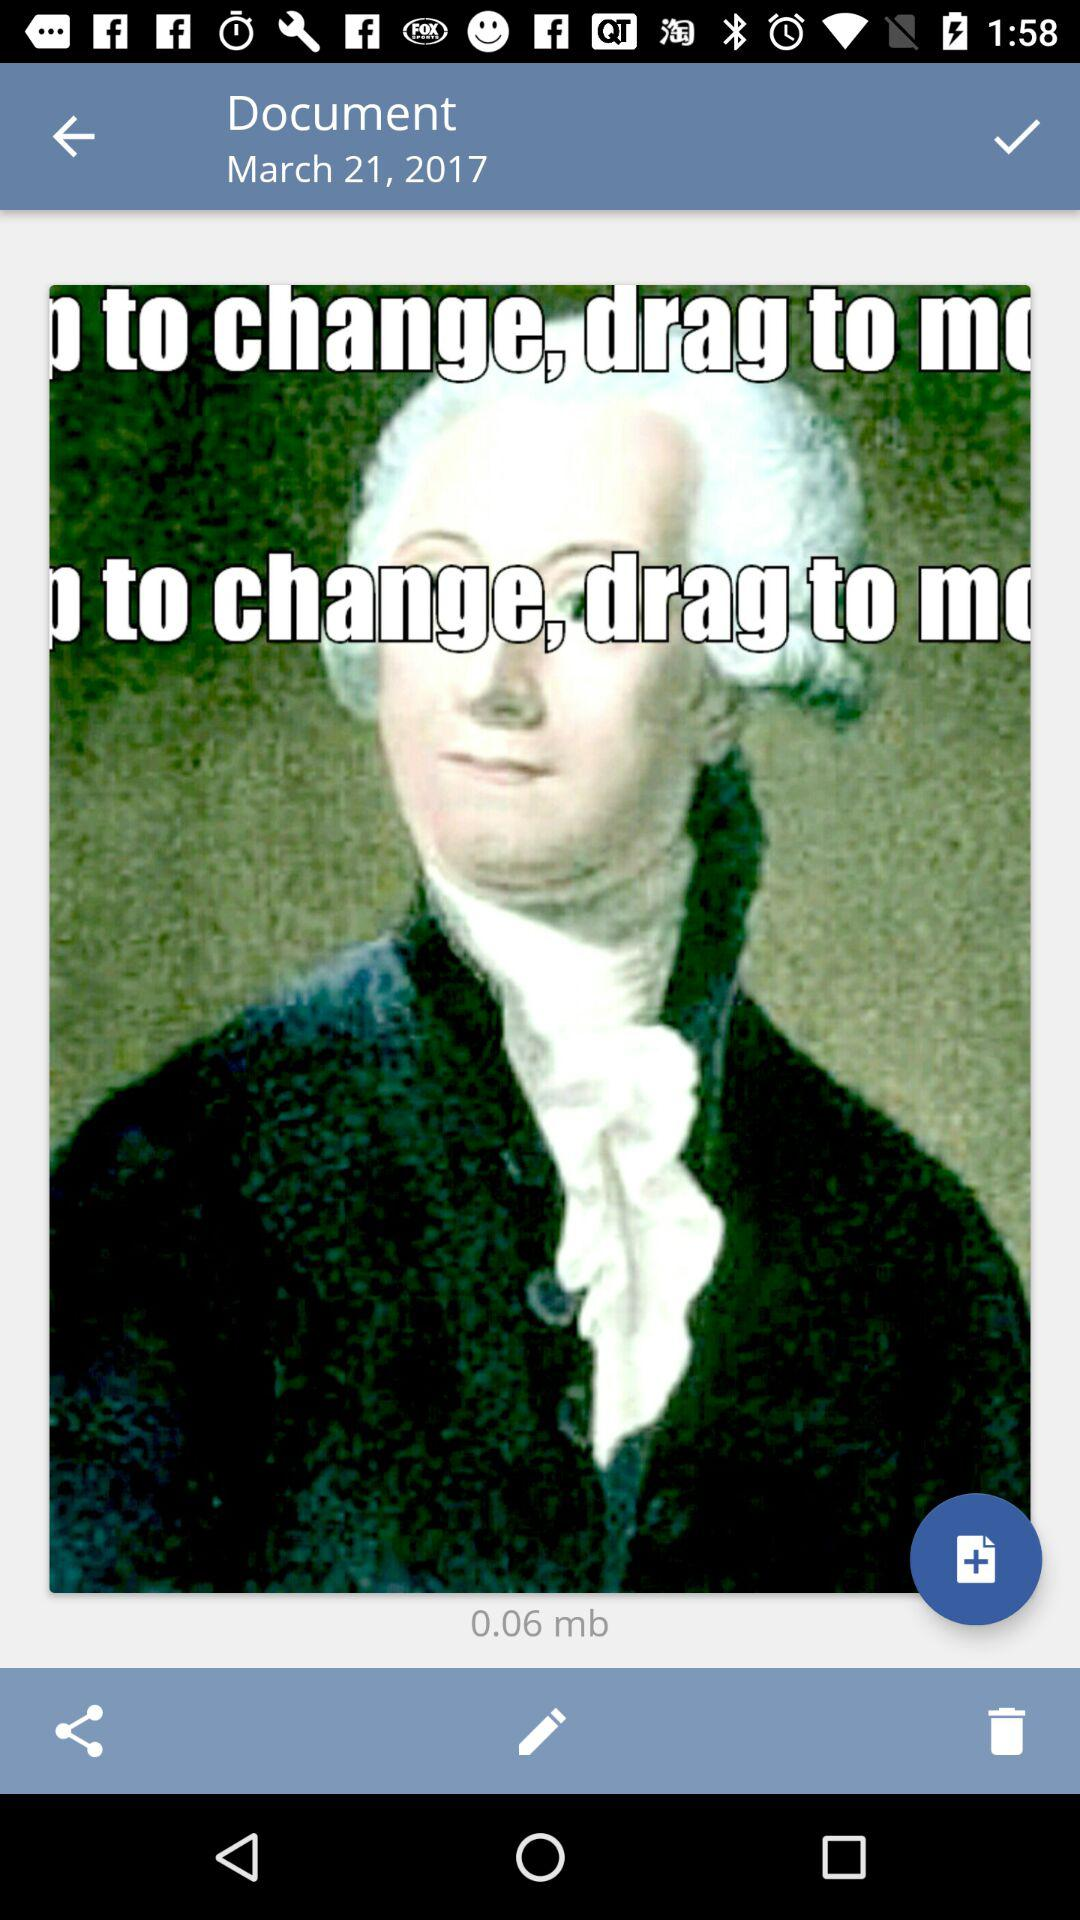What is the size of the image? The size of the image is 0.06 mb. 